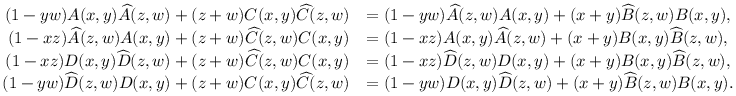Convert formula to latex. <formula><loc_0><loc_0><loc_500><loc_500>\begin{array} { r l } { ( 1 - y w ) A ( x , y ) \widehat { A } ( z , w ) + ( z + w ) C ( x , y ) \widehat { C } ( z , w ) } & { = ( 1 - y w ) \widehat { A } ( z , w ) A ( x , y ) + ( x + y ) \widehat { B } ( z , w ) B ( x , y ) , } \\ { ( 1 - x z ) \widehat { A } ( z , w ) A ( x , y ) + ( z + w ) \widehat { C } ( z , w ) C ( x , y ) } & { = ( 1 - x z ) A ( x , y ) \widehat { A } ( z , w ) + ( x + y ) B ( x , y ) \widehat { B } ( z , w ) , } \\ { ( 1 - x z ) D ( x , y ) \widehat { D } ( z , w ) + ( z + w ) \widehat { C } ( z , w ) C ( x , y ) } & { = ( 1 - x z ) \widehat { D } ( z , w ) D ( x , y ) + ( x + y ) B ( x , y ) \widehat { B } ( z , w ) , } \\ { ( 1 - y w ) \widehat { D } ( z , w ) D ( x , y ) + ( z + w ) C ( x , y ) \widehat { C } ( z , w ) } & { = ( 1 - y w ) D ( x , y ) \widehat { D } ( z , w ) + ( x + y ) \widehat { B } ( z , w ) B ( x , y ) . } \end{array}</formula> 